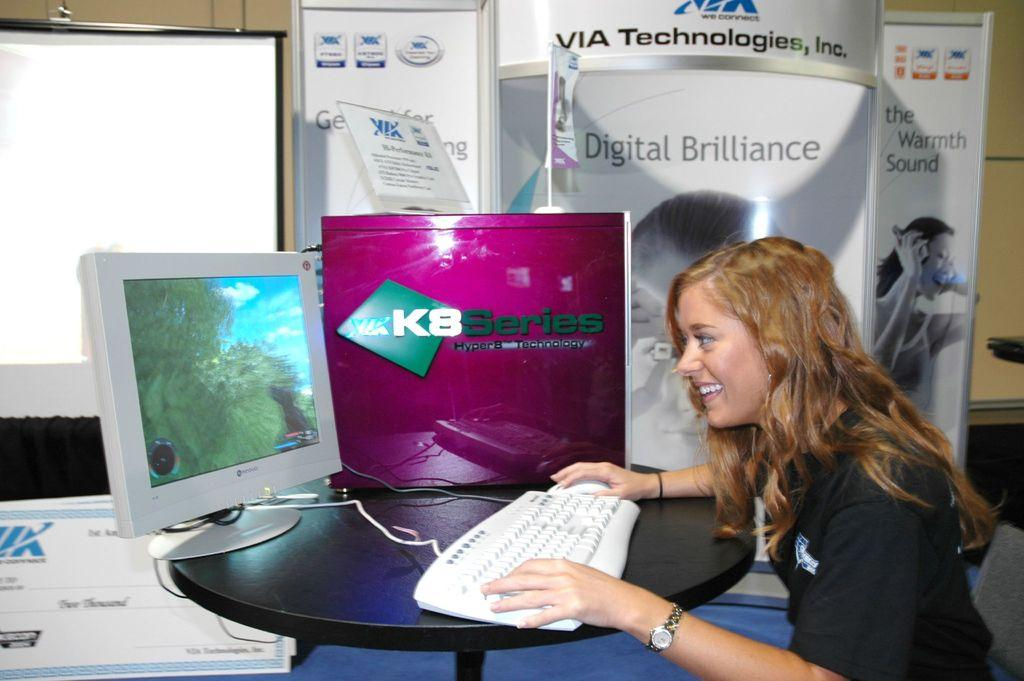<image>
Give a short and clear explanation of the subsequent image. A woman at a place that is promoting VIA technologies. 